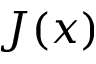Convert formula to latex. <formula><loc_0><loc_0><loc_500><loc_500>J ( x )</formula> 